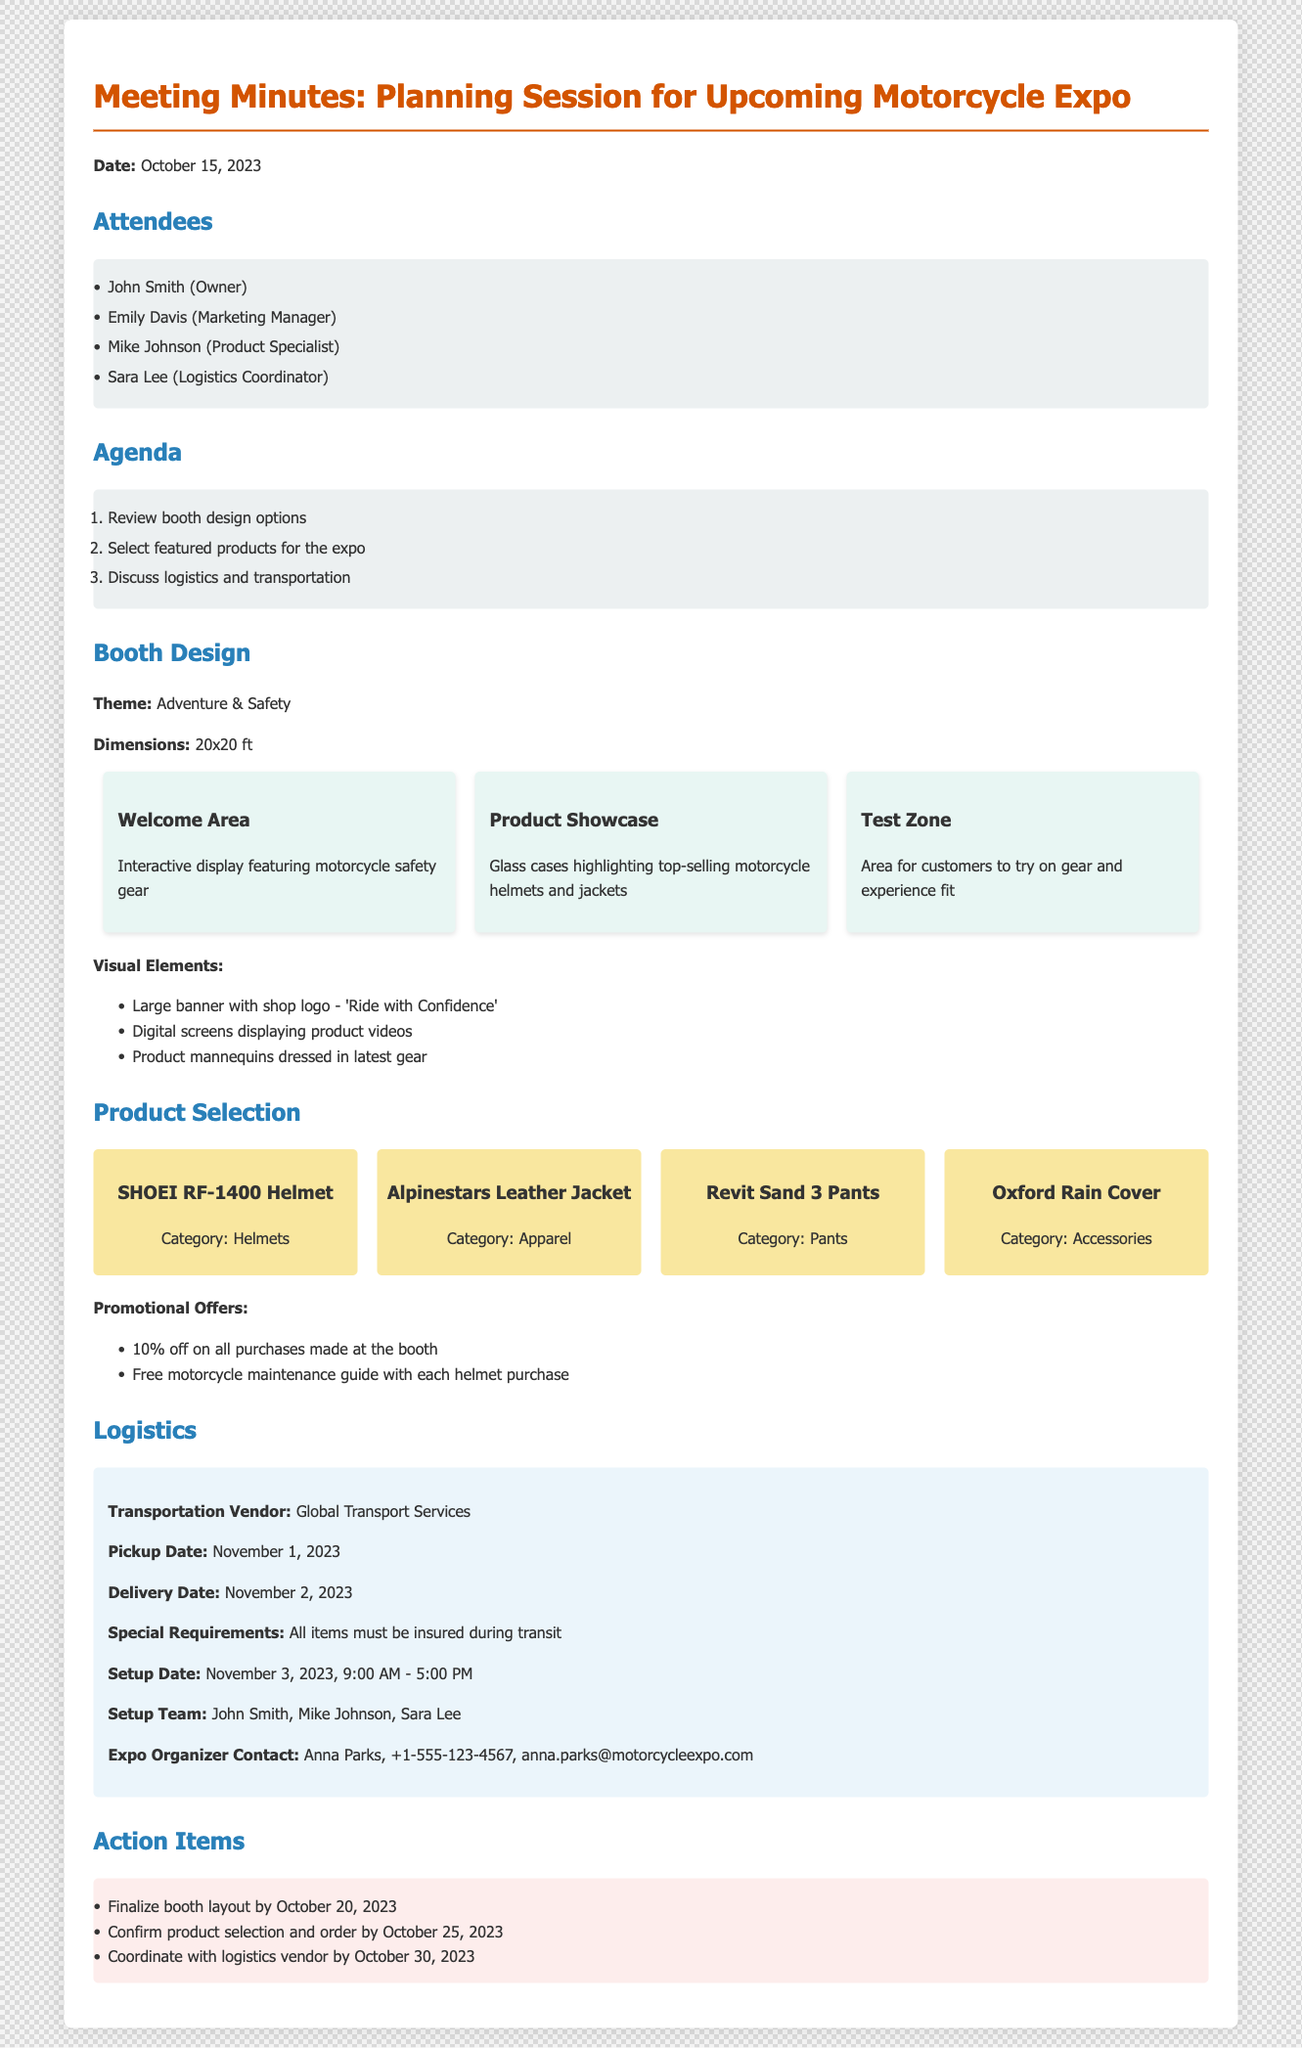what is the date of the planning session? The date is explicitly mentioned in the document under "Date."
Answer: October 15, 2023 who is the marketing manager present in the meeting? The name of the marketing manager is listed under "Attendees."
Answer: Emily Davis what are the dimensions of the booth? The dimensions are specified in the "Booth Design" section.
Answer: 20x20 ft what promotional offer is available for helmet purchases? The promotional offers are detailed under "Promotional Offers."
Answer: Free motorcycle maintenance guide who is the contact person for the expo organizer? The contact information for the expo organizer is provided in the "Logistics" section.
Answer: Anna Parks when is the setup date for the booth? The setup date is listed in the "Logistics" section.
Answer: November 3, 2023 how many action items are listed in the document? The number of action items can be counted in the "Action Items" section.
Answer: 3 what is the theme of the booth? The theme is mentioned in the "Booth Design" section.
Answer: Adventure & Safety what type of displays will be featured in the welcome area? The type of display is described in the "Booth Design" section.
Answer: Interactive display featuring motorcycle safety gear 